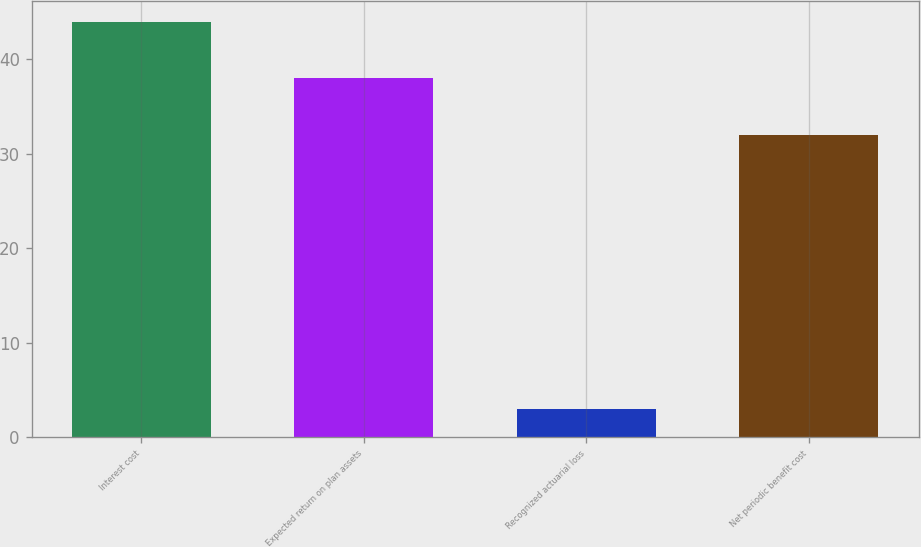<chart> <loc_0><loc_0><loc_500><loc_500><bar_chart><fcel>Interest cost<fcel>Expected return on plan assets<fcel>Recognized actuarial loss<fcel>Net periodic benefit cost<nl><fcel>44<fcel>38<fcel>3<fcel>32<nl></chart> 